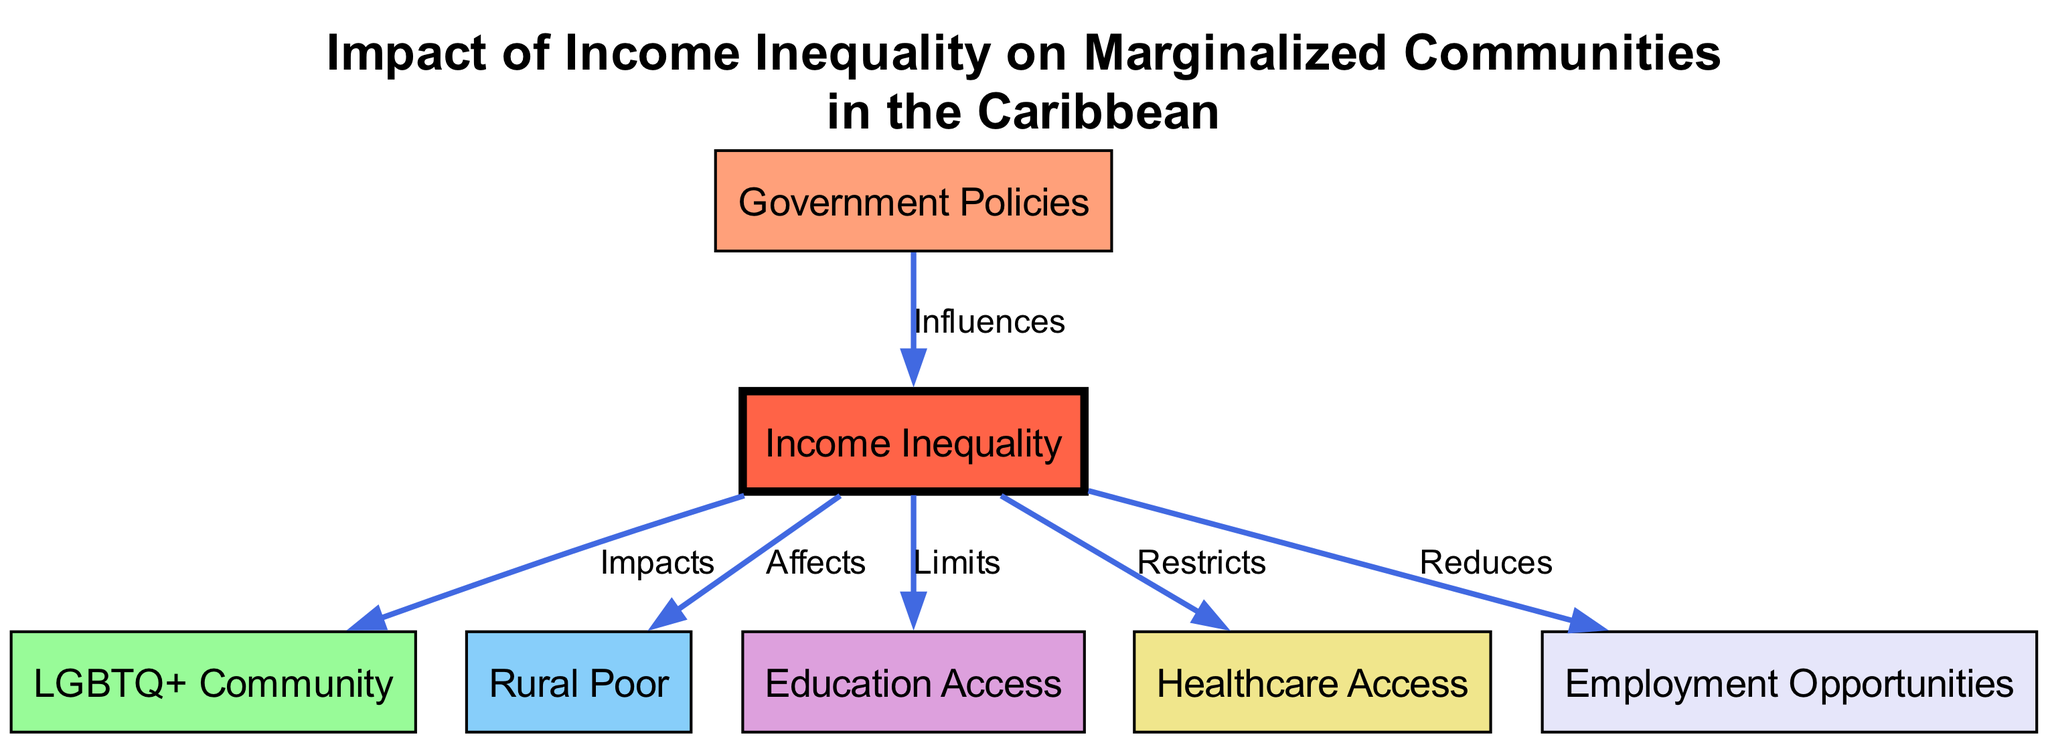What is the central node of the diagram? The central node is identified as "Income Inequality," which is the primary focus of this diagram. It is visually highlighted in a different color, making it stand out as the main topic.
Answer: Income Inequality How many nodes are present in the diagram? To determine the number of nodes, we can count each individual node from the list provided. There are 7 distinct nodes represented in the diagram.
Answer: 7 What type of relationship exists between "Income Inequality" and the "LGBTQ+ Community"? The relationship is labeled "Impacts," indicating that income inequality has a direct effect on the LGBTQ+ community. This connection shows one of the ways inequality can influence marginalized groups.
Answer: Impacts Which node is affected by income inequality in rural areas? The node representing "Rural Poor" is connected to "Income Inequality" with the label "Affects," suggesting that those living in rural areas suffer from the effects of income inequality.
Answer: Rural Poor What does "Government Policies" do to "Income Inequality"? The edge from "Government Policies" to "Income Inequality" is labeled "Influences," which indicates that government actions or policies can change the levels of income inequality in society.
Answer: Influences How many edges connect to the "Income Inequality" node? By analyzing the diagram, we can see that there are 5 edges connected to the "Income Inequality" node, each representing different relationships to other marginalized communities and access issues.
Answer: 5 What does income inequality limit in marginalized communities? The diagram shows that "Income Inequality" "Limits" access to "Education Access," indicating that individuals in marginalized communities face challenges in obtaining education due to income disparity.
Answer: Education Access Which marginalized community is specifically mentioned in the diagram? Two specific marginalized communities are represented: "LGBTQ+ Community" and "Rural Poor," both connected to the notion of income inequality which affects them differently.
Answer: LGBTQ+ Community, Rural Poor 